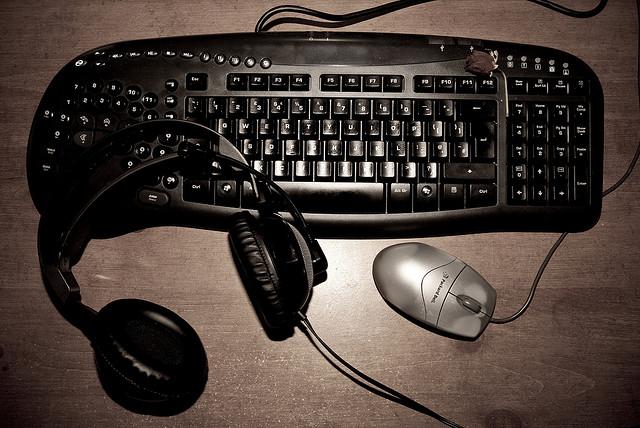What is next to the mouse,and headphone?
Keep it brief. Keyboard. Is this keyboard in danger of being stepped on?
Be succinct. No. What brand is the mouse?
Write a very short answer. Microsoft. Are any of these objects wireless?
Quick response, please. No. 